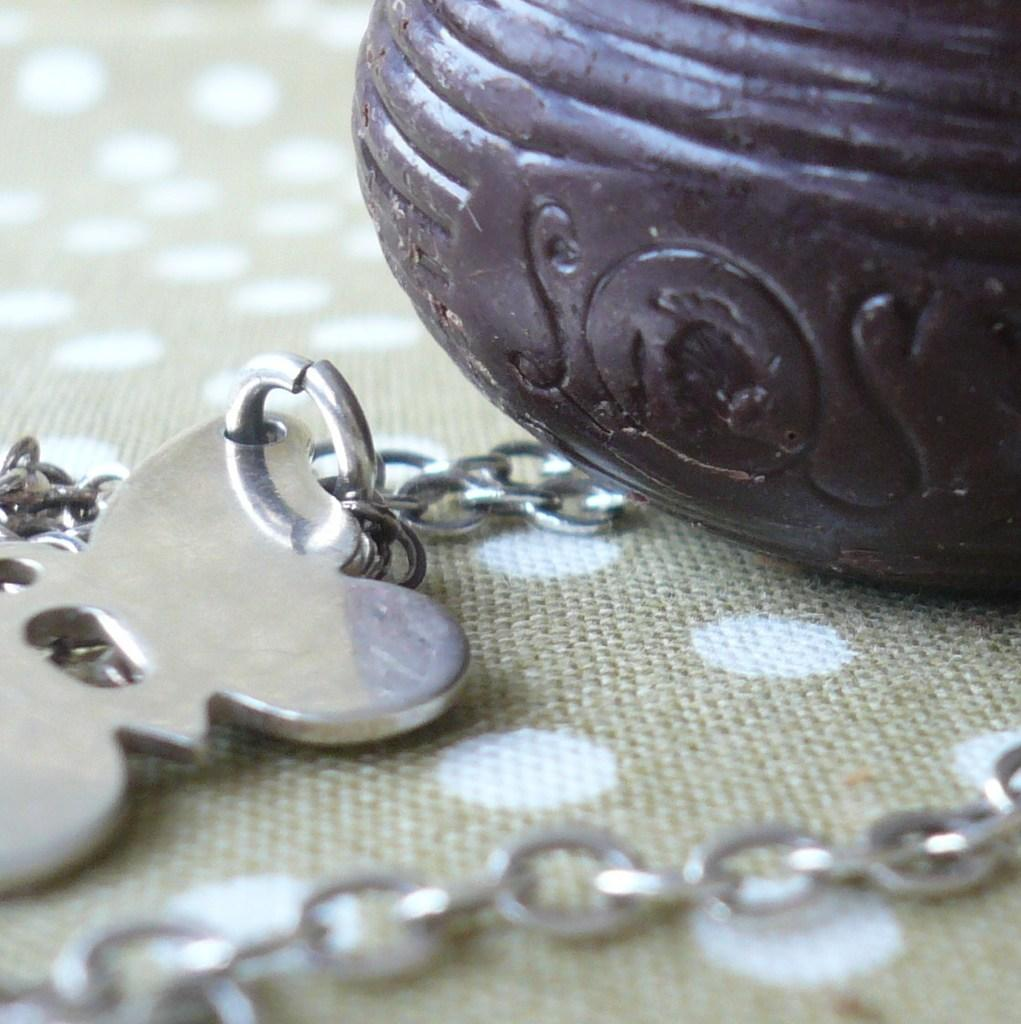What is the color of the object in the image? The object in the image has a brown color. What item is present in the image along with the brown object? There is a key chain in the image. Where is the key chain placed? The key chain is placed on a mat. Can you see the person crushing the basketball in the image? There is no person or basketball present in the image. 